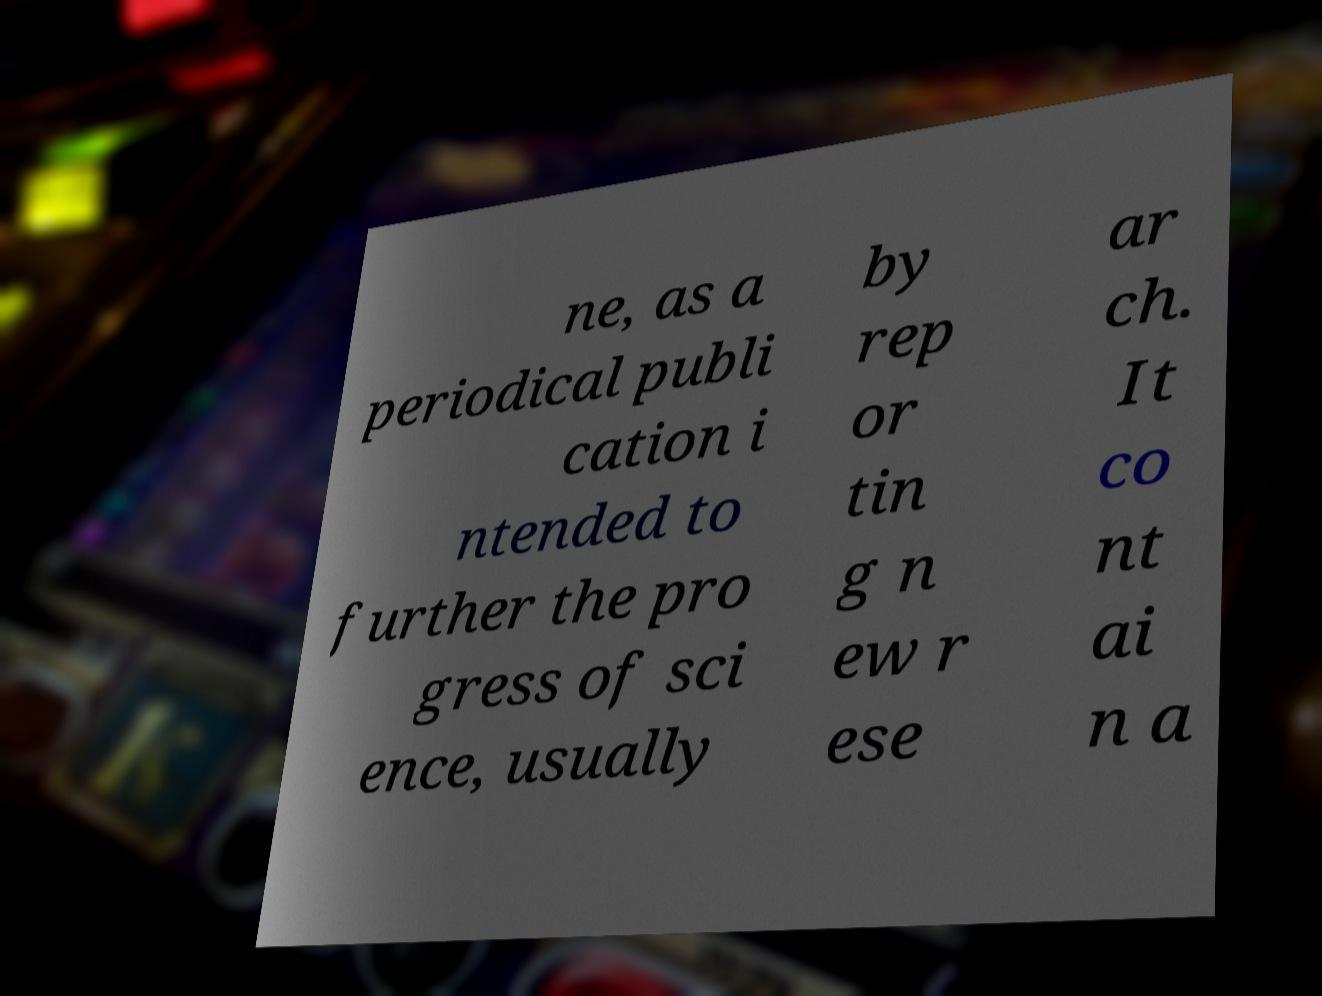For documentation purposes, I need the text within this image transcribed. Could you provide that? ne, as a periodical publi cation i ntended to further the pro gress of sci ence, usually by rep or tin g n ew r ese ar ch. It co nt ai n a 